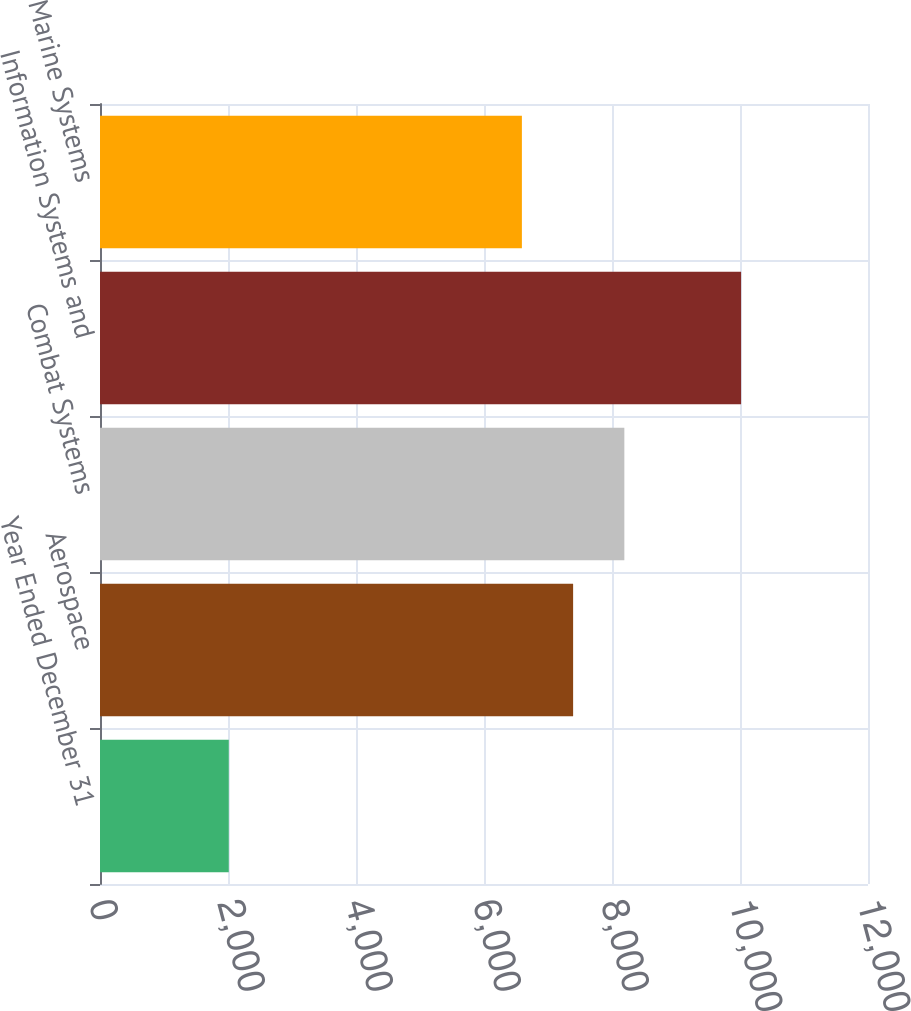Convert chart to OTSL. <chart><loc_0><loc_0><loc_500><loc_500><bar_chart><fcel>Year Ended December 31<fcel>Aerospace<fcel>Combat Systems<fcel>Information Systems and<fcel>Marine Systems<nl><fcel>2012<fcel>7392.5<fcel>8193<fcel>10017<fcel>6592<nl></chart> 